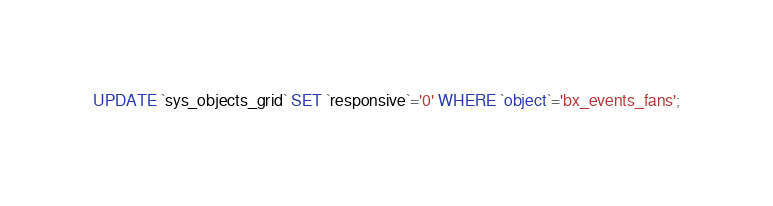Convert code to text. <code><loc_0><loc_0><loc_500><loc_500><_SQL_>UPDATE `sys_objects_grid` SET `responsive`='0' WHERE `object`='bx_events_fans';
</code> 